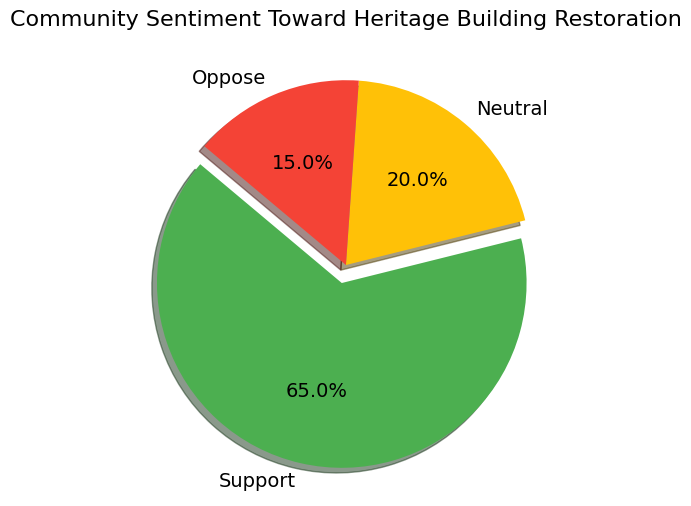What percentage of the community supports the restoration? The 'Support' section of the pie chart is labeled with a percentage. By observing this part of the chart, we see it says 65%.
Answer: 65% Which sentiment group has the least support? By comparing the sizes of the segments and their percentages, the 'Oppose' section accounts for 15%, which is the smallest number.
Answer: Oppose How much higher is the percentage of people who support the restoration compared to those who oppose it? The 'Support' percentage is 65%, and the 'Oppose' percentage is 15%. Subtract 15 from 65 to find the difference.
Answer: 50% What is the combined percentage of people who are neutral or oppose the restoration? The 'Neutral' section is 20%, and the 'Oppose' section is 15%. Add these two percentages together: 20% + 15% = 35%.
Answer: 35% Which section of the pie chart is color-coded in green? The 'Support' section is visually represented with green color in the pie chart.
Answer: Support Is the percentage of people who are neutral greater than those who oppose the restoration? By comparing the labels on the pie chart, 'Neutral' is 20% and 'Oppose' is 15%. Since 20% is greater than 15%, 'Neutral' is indeed greater.
Answer: Yes If the community size is 1000 people, how many people support the restoration? To find the number of people, multiply the total community size by the percentage supporting: 1000 * 65% (0.65) = 650.
Answer: 650 By how many percentage points does the 'Support' section exceed the combined percentages of 'Neutral' and 'Oppose'? The 'Support' section is 65%, and the combined percentage of 'Neutral' and 'Oppose' is 35%. Subtract the combined percentage from 'Support': 65% - 35% = 30%.
Answer: 30% Which segment has the second-largest size in the pie chart? By visually comparing the segments, after the 'Support' section, the 'Neutral' section is the second-largest, representing 20%.
Answer: Neutral 